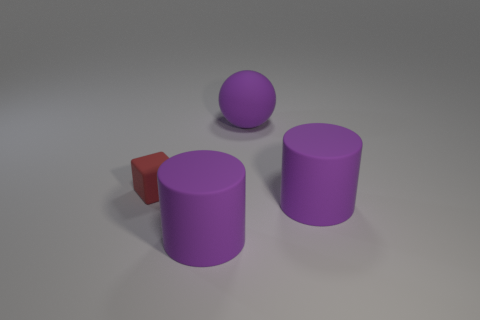Is there any other thing that is the same size as the red rubber block?
Provide a short and direct response. No. Are there fewer big spheres in front of the small red rubber thing than purple things?
Keep it short and to the point. Yes. The small red object that is made of the same material as the purple ball is what shape?
Your response must be concise. Cube. Do the cube and the big ball have the same material?
Your answer should be very brief. Yes. Is the number of large things that are left of the small matte block less than the number of red matte objects behind the large matte ball?
Your answer should be compact. No. What number of small objects are on the left side of the thing that is on the right side of the big purple matte object that is behind the block?
Ensure brevity in your answer.  1. Is the color of the matte cube the same as the matte sphere?
Provide a short and direct response. No. Is there a big matte object that has the same color as the large ball?
Offer a terse response. Yes. Are there any large yellow matte objects of the same shape as the red object?
Your response must be concise. No. There is a purple rubber cylinder that is right of the large rubber object that is behind the red rubber object; are there any big rubber objects that are right of it?
Your answer should be very brief. No. 